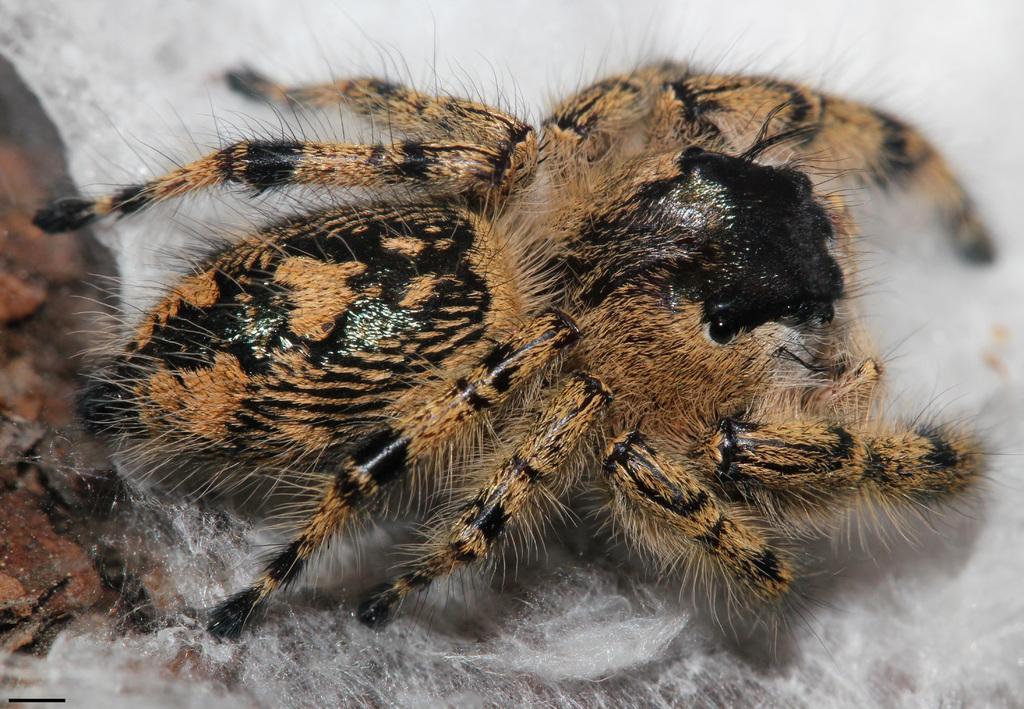Describe this image in one or two sentences. In this image there is a spider on the path. 